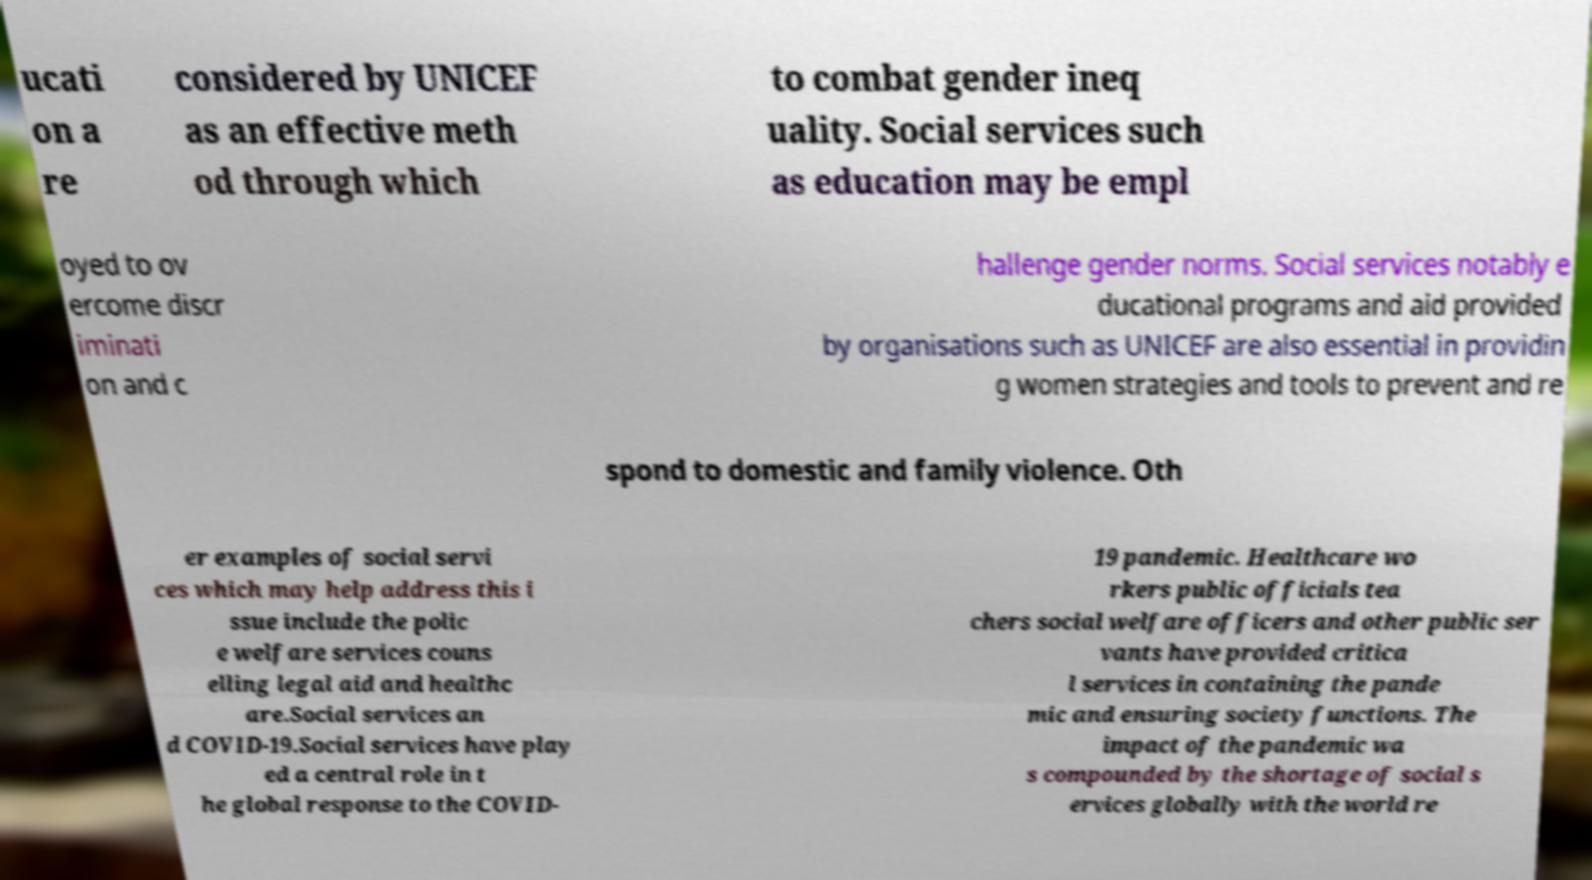I need the written content from this picture converted into text. Can you do that? ucati on a re considered by UNICEF as an effective meth od through which to combat gender ineq uality. Social services such as education may be empl oyed to ov ercome discr iminati on and c hallenge gender norms. Social services notably e ducational programs and aid provided by organisations such as UNICEF are also essential in providin g women strategies and tools to prevent and re spond to domestic and family violence. Oth er examples of social servi ces which may help address this i ssue include the polic e welfare services couns elling legal aid and healthc are.Social services an d COVID-19.Social services have play ed a central role in t he global response to the COVID- 19 pandemic. Healthcare wo rkers public officials tea chers social welfare officers and other public ser vants have provided critica l services in containing the pande mic and ensuring society functions. The impact of the pandemic wa s compounded by the shortage of social s ervices globally with the world re 